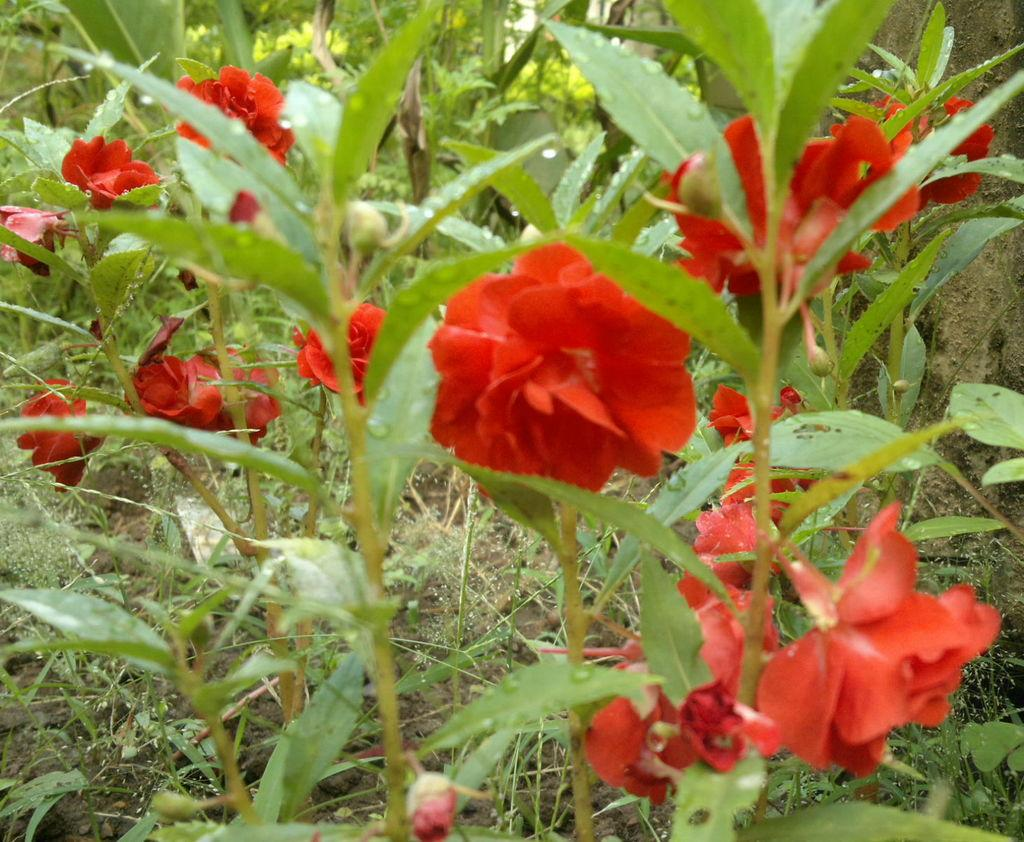What type of flora can be seen in the image? There are flowers and plants in the image. What color are the flowers in the image? The flowers in the image are red in color. What type of vegetation is present at the bottom of the image? Grass is present at the bottom of the image. How many dogs can be seen playing with the flowers in the image? There are no dogs present in the image; it features flowers, plants, and grass. What direction does the wren fly in the image? There is no wren present in the image. 